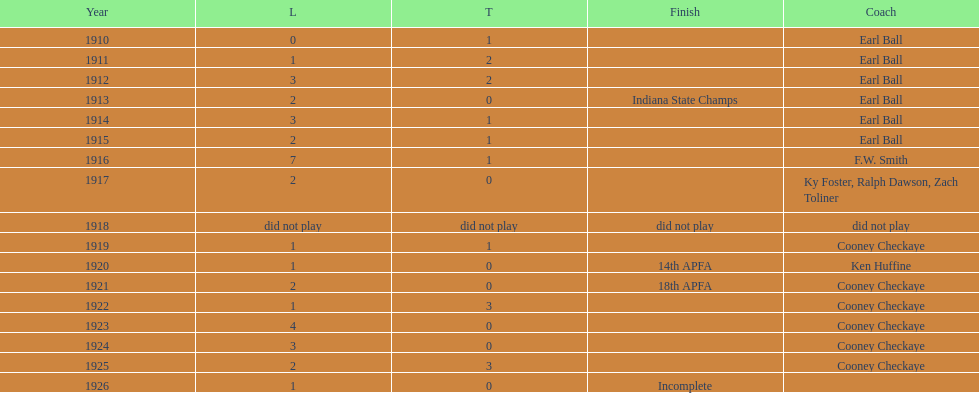In what year did the muncie flyers have an undefeated record? 1910. 